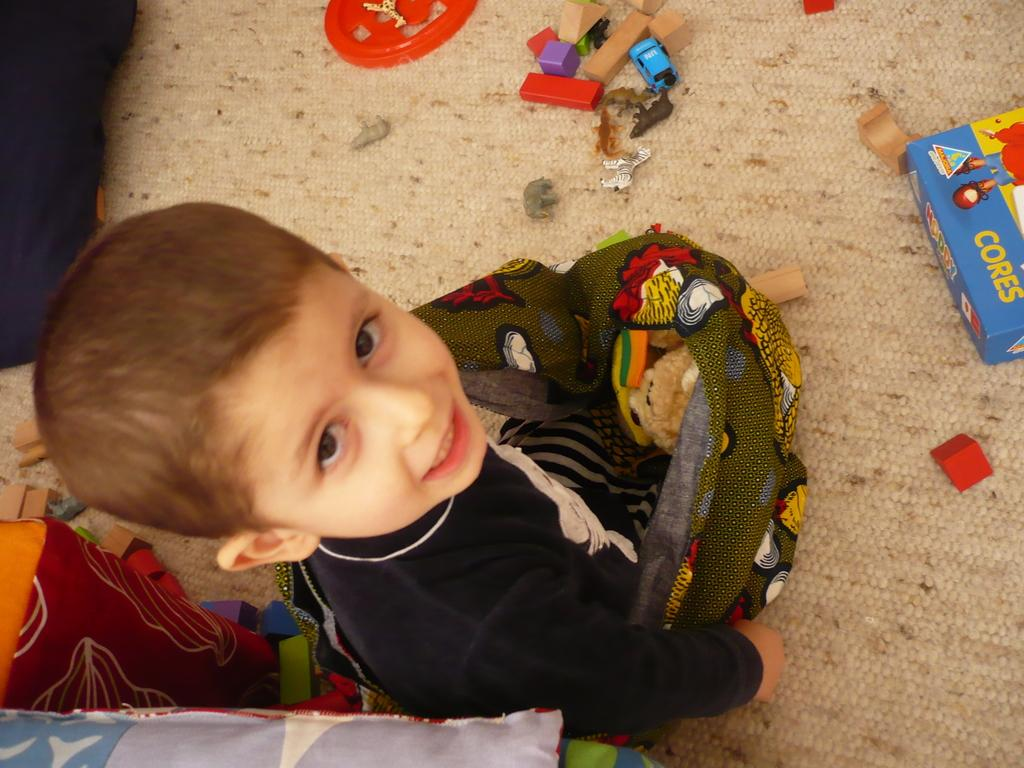What is the main subject in the foreground of the image? There is a small boy in the foreground of the image. What is the boy doing in the image? The boy is holding some objects. What can be seen on the floor in the image? There are toys and other objects on the floor. What nation is the boy representing in the image? There is no indication in the image that the boy is representing any nation. How does the boy smash the objects he is holding in the image? The boy is not smashing any objects in the image; he is simply holding them. 